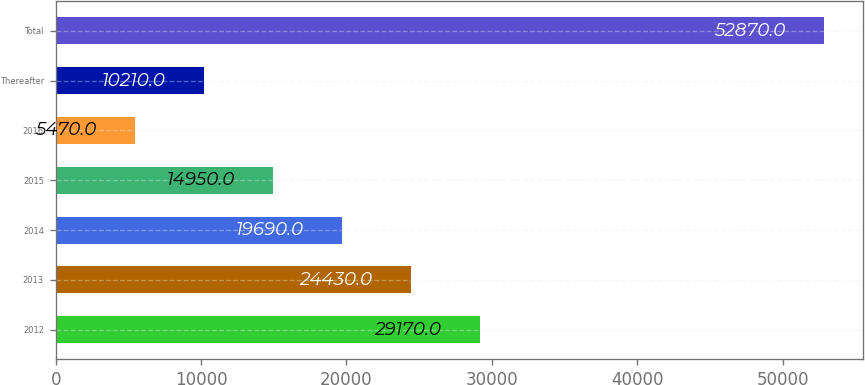Convert chart. <chart><loc_0><loc_0><loc_500><loc_500><bar_chart><fcel>2012<fcel>2013<fcel>2014<fcel>2015<fcel>2016<fcel>Thereafter<fcel>Total<nl><fcel>29170<fcel>24430<fcel>19690<fcel>14950<fcel>5470<fcel>10210<fcel>52870<nl></chart> 